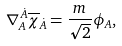<formula> <loc_0><loc_0><loc_500><loc_500>\nabla _ { A } ^ { \, \dot { A } } \overline { \chi } _ { \dot { A } } = \frac { m } { \sqrt { 2 } } \phi _ { A } ,</formula> 